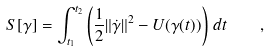Convert formula to latex. <formula><loc_0><loc_0><loc_500><loc_500>S [ \gamma ] = \int _ { t _ { 1 } } ^ { t _ { 2 } } \left ( \frac { 1 } { 2 } \| \dot { \gamma } \| ^ { 2 } - U ( \gamma ( t ) ) \right ) \, d t \quad ,</formula> 